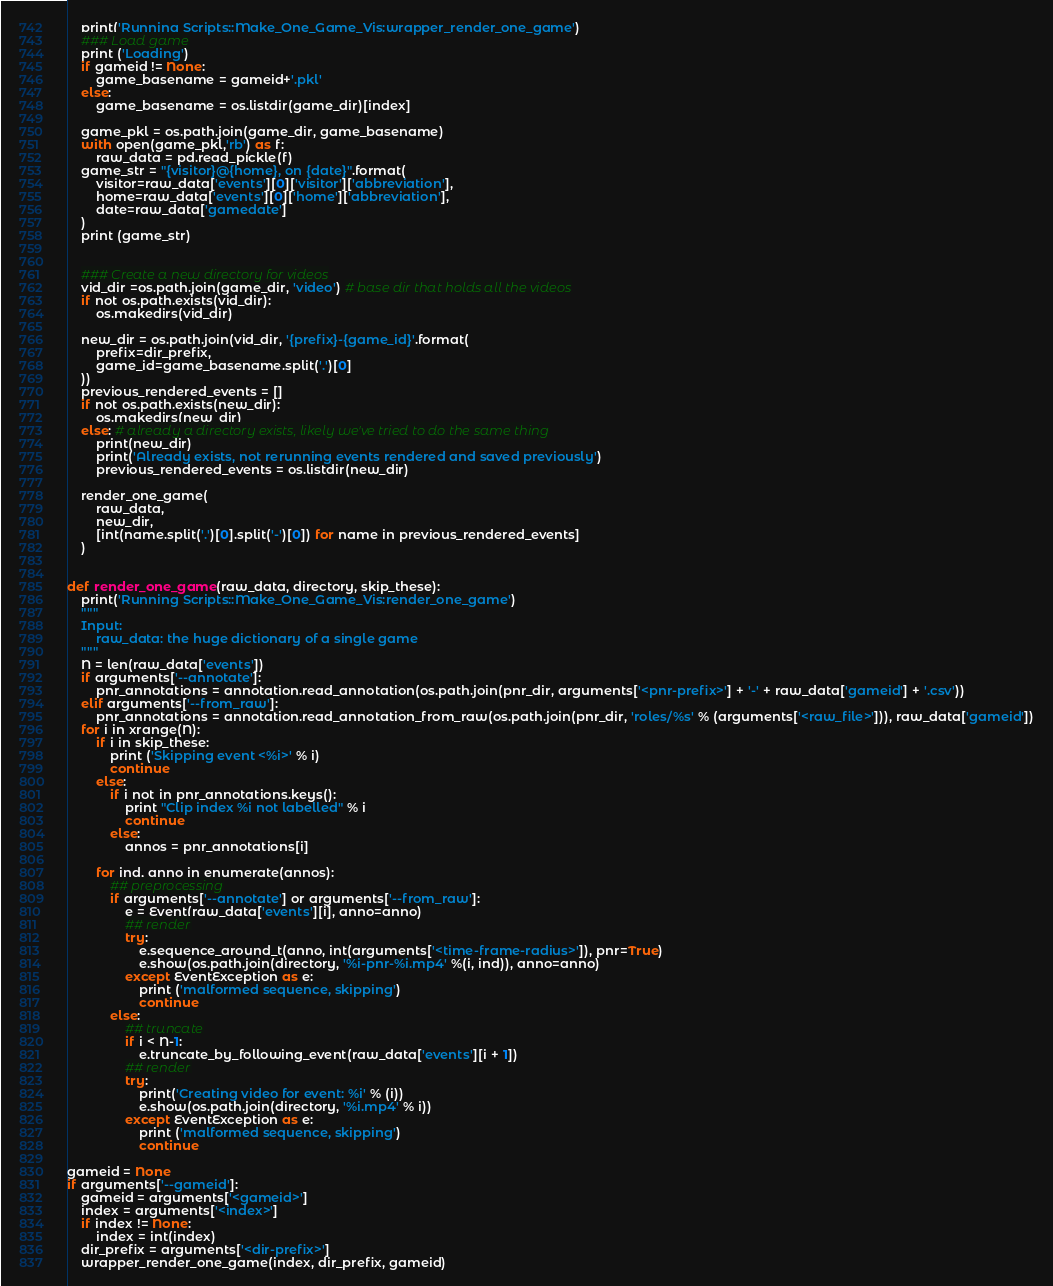<code> <loc_0><loc_0><loc_500><loc_500><_Python_>    print('Running Scripts::Make_One_Game_Vis:wrapper_render_one_game')
    ### Load game
    print ('Loading')
    if gameid != None:
        game_basename = gameid+'.pkl'
    else:
        game_basename = os.listdir(game_dir)[index]

    game_pkl = os.path.join(game_dir, game_basename)
    with open(game_pkl,'rb') as f:
        raw_data = pd.read_pickle(f)
    game_str = "{visitor}@{home}, on {date}".format(
        visitor=raw_data['events'][0]['visitor']['abbreviation'],
        home=raw_data['events'][0]['home']['abbreviation'],
        date=raw_data['gamedate']
    )
    print (game_str)


    ### Create a new directory for videos
    vid_dir =os.path.join(game_dir, 'video') # base dir that holds all the videos
    if not os.path.exists(vid_dir):
        os.makedirs(vid_dir)

    new_dir = os.path.join(vid_dir, '{prefix}-{game_id}'.format(
        prefix=dir_prefix,
        game_id=game_basename.split('.')[0]
    ))
    previous_rendered_events = []
    if not os.path.exists(new_dir):
        os.makedirs(new_dir)
    else: # already a directory exists, likely we've tried to do the same thing
        print(new_dir)
        print('Already exists, not rerunning events rendered and saved previously')
        previous_rendered_events = os.listdir(new_dir)

    render_one_game(
        raw_data,
        new_dir,
        [int(name.split('.')[0].split('-')[0]) for name in previous_rendered_events]
    )


def render_one_game(raw_data, directory, skip_these):
    print('Running Scripts::Make_One_Game_Vis:render_one_game')
    """
    Input:
        raw_data: the huge dictionary of a single game
    """
    N = len(raw_data['events'])
    if arguments['--annotate']:
        pnr_annotations = annotation.read_annotation(os.path.join(pnr_dir, arguments['<pnr-prefix>'] + '-' + raw_data['gameid'] + '.csv'))
    elif arguments['--from_raw']:
        pnr_annotations = annotation.read_annotation_from_raw(os.path.join(pnr_dir, 'roles/%s' % (arguments['<raw_file>'])), raw_data['gameid'])
    for i in xrange(N):
        if i in skip_these:
            print ('Skipping event <%i>' % i)
            continue
        else:
            if i not in pnr_annotations.keys():
                print "Clip index %i not labelled" % i
                continue
            else:
                annos = pnr_annotations[i]

        for ind, anno in enumerate(annos):
            ## preprocessing
            if arguments['--annotate'] or arguments['--from_raw']:
                e = Event(raw_data['events'][i], anno=anno)
                ## render
                try:
                    e.sequence_around_t(anno, int(arguments['<time-frame-radius>']), pnr=True)
                    e.show(os.path.join(directory, '%i-pnr-%i.mp4' %(i, ind)), anno=anno)
                except EventException as e:
                    print ('malformed sequence, skipping')
                    continue
            else:
                ## truncate
                if i < N-1:
                    e.truncate_by_following_event(raw_data['events'][i + 1])
                ## render
                try:
                    print('Creating video for event: %i' % (i))
                    e.show(os.path.join(directory, '%i.mp4' % i))
                except EventException as e:
                    print ('malformed sequence, skipping')
                    continue

gameid = None
if arguments['--gameid']:
    gameid = arguments['<gameid>']
    index = arguments['<index>']
    if index != None:
        index = int(index)
    dir_prefix = arguments['<dir-prefix>']
    wrapper_render_one_game(index, dir_prefix, gameid)</code> 